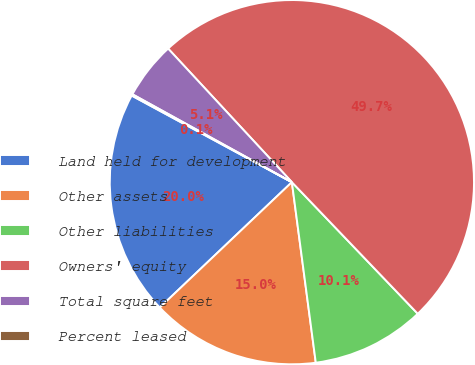Convert chart to OTSL. <chart><loc_0><loc_0><loc_500><loc_500><pie_chart><fcel>Land held for development<fcel>Other assets<fcel>Other liabilities<fcel>Owners' equity<fcel>Total square feet<fcel>Percent leased<nl><fcel>19.97%<fcel>15.01%<fcel>10.05%<fcel>49.74%<fcel>5.09%<fcel>0.13%<nl></chart> 